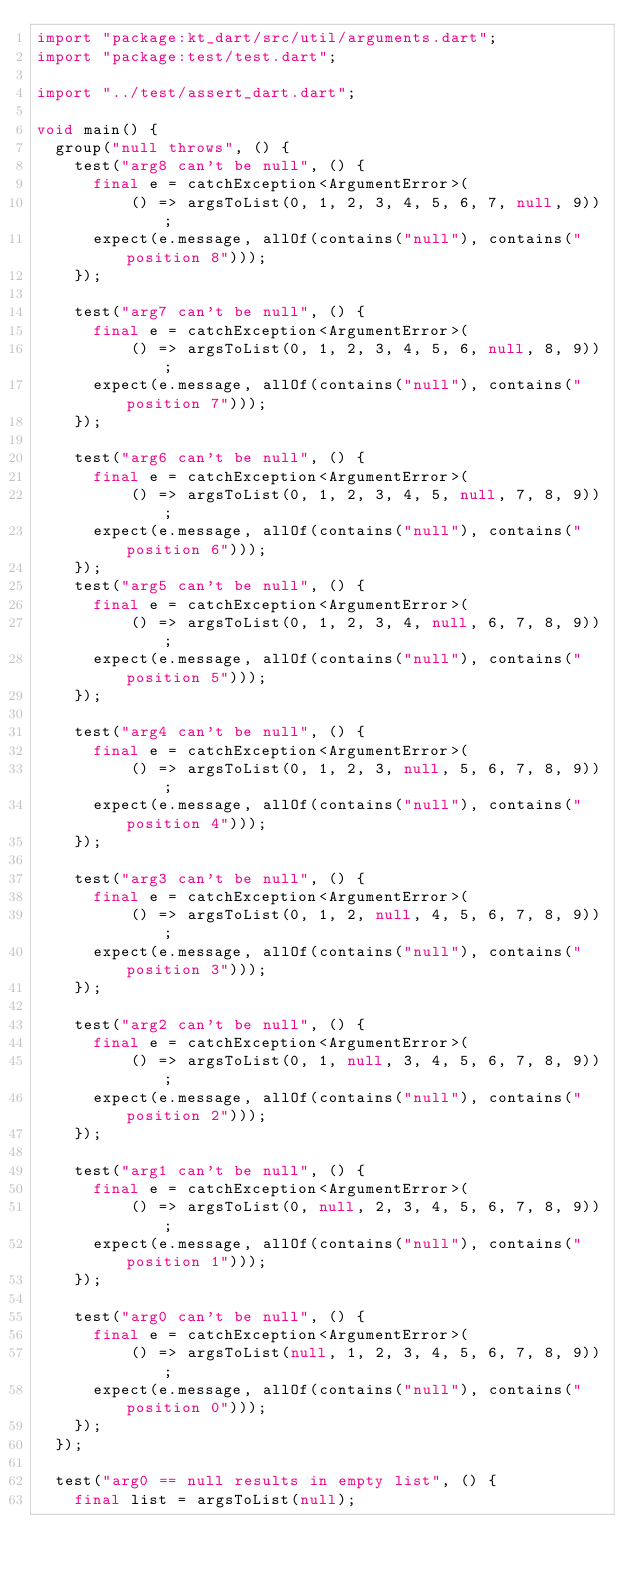Convert code to text. <code><loc_0><loc_0><loc_500><loc_500><_Dart_>import "package:kt_dart/src/util/arguments.dart";
import "package:test/test.dart";

import "../test/assert_dart.dart";

void main() {
  group("null throws", () {
    test("arg8 can't be null", () {
      final e = catchException<ArgumentError>(
          () => argsToList(0, 1, 2, 3, 4, 5, 6, 7, null, 9));
      expect(e.message, allOf(contains("null"), contains("position 8")));
    });

    test("arg7 can't be null", () {
      final e = catchException<ArgumentError>(
          () => argsToList(0, 1, 2, 3, 4, 5, 6, null, 8, 9));
      expect(e.message, allOf(contains("null"), contains("position 7")));
    });

    test("arg6 can't be null", () {
      final e = catchException<ArgumentError>(
          () => argsToList(0, 1, 2, 3, 4, 5, null, 7, 8, 9));
      expect(e.message, allOf(contains("null"), contains("position 6")));
    });
    test("arg5 can't be null", () {
      final e = catchException<ArgumentError>(
          () => argsToList(0, 1, 2, 3, 4, null, 6, 7, 8, 9));
      expect(e.message, allOf(contains("null"), contains("position 5")));
    });

    test("arg4 can't be null", () {
      final e = catchException<ArgumentError>(
          () => argsToList(0, 1, 2, 3, null, 5, 6, 7, 8, 9));
      expect(e.message, allOf(contains("null"), contains("position 4")));
    });

    test("arg3 can't be null", () {
      final e = catchException<ArgumentError>(
          () => argsToList(0, 1, 2, null, 4, 5, 6, 7, 8, 9));
      expect(e.message, allOf(contains("null"), contains("position 3")));
    });

    test("arg2 can't be null", () {
      final e = catchException<ArgumentError>(
          () => argsToList(0, 1, null, 3, 4, 5, 6, 7, 8, 9));
      expect(e.message, allOf(contains("null"), contains("position 2")));
    });

    test("arg1 can't be null", () {
      final e = catchException<ArgumentError>(
          () => argsToList(0, null, 2, 3, 4, 5, 6, 7, 8, 9));
      expect(e.message, allOf(contains("null"), contains("position 1")));
    });

    test("arg0 can't be null", () {
      final e = catchException<ArgumentError>(
          () => argsToList(null, 1, 2, 3, 4, 5, 6, 7, 8, 9));
      expect(e.message, allOf(contains("null"), contains("position 0")));
    });
  });

  test("arg0 == null results in empty list", () {
    final list = argsToList(null);</code> 